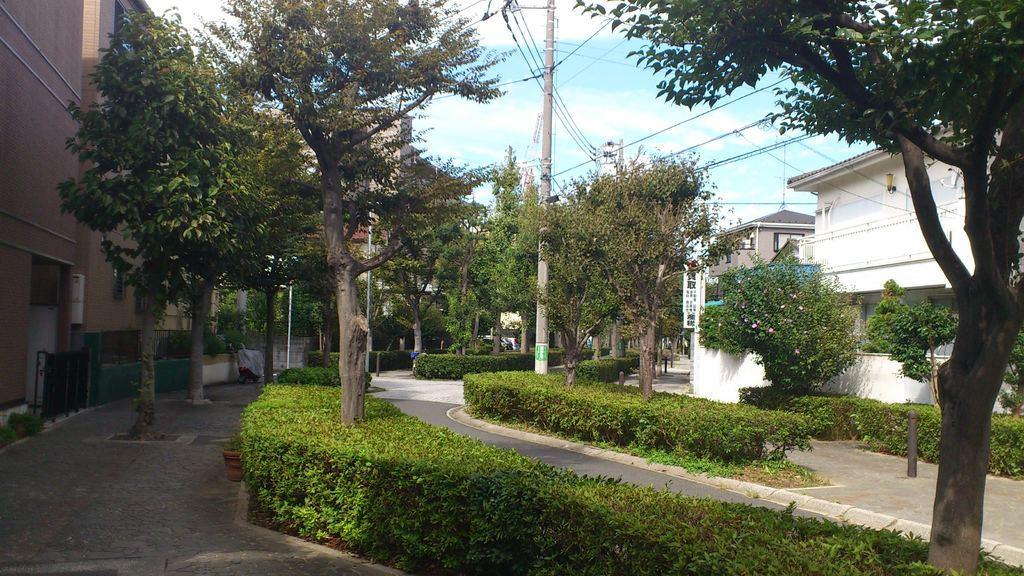Can you describe this image briefly? On the left side of the image and right side of the image there are houses, trees, plants, poles and board. In the middle of the image I can see a pole, bushes and cloudy sky. 